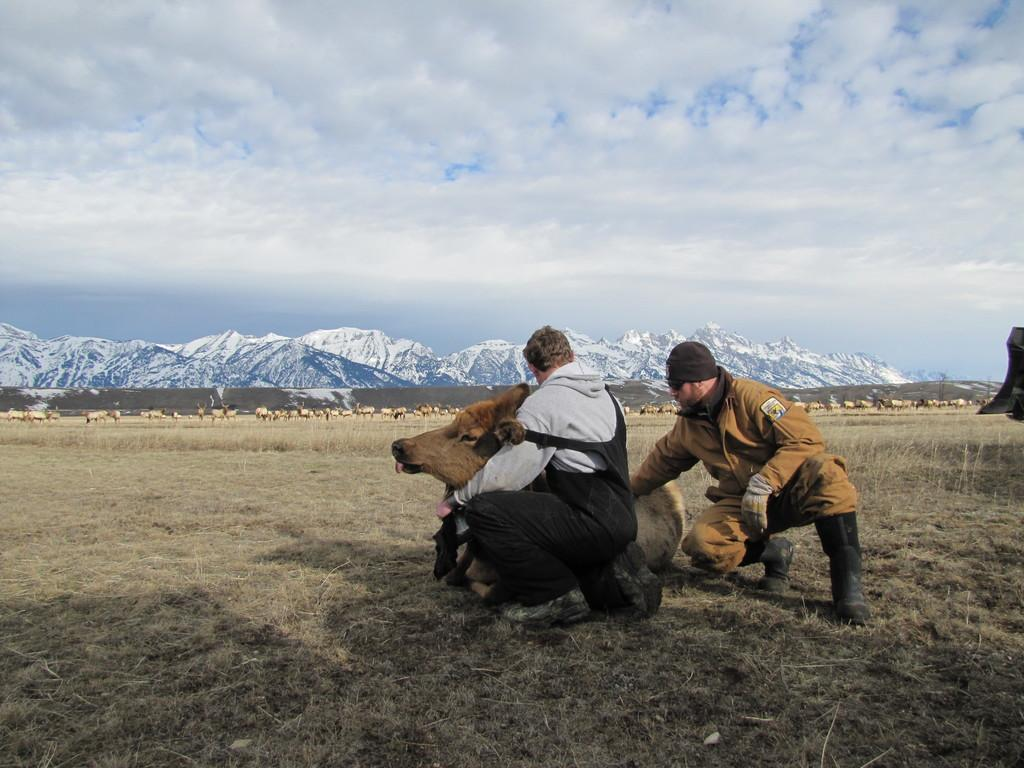What are the two people in the image doing? The two people are sitting in a squat position. What is on the grass in the image? There is an animal on the grass. What can be seen in the background of the image? The background of the image includes animals and hills, as well as the sky. What type of volcano can be seen erupting in the background of the image? There is no volcano present in the image; the background features hills and animals. How many women are present in the image? The image only shows two people, both of whom are sitting in a squat position, so there are no women present. 